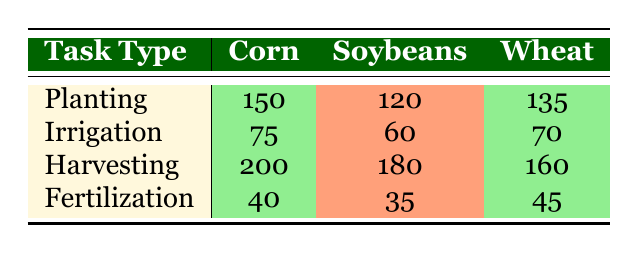What is the total number of labor hours utilized for irrigation across all crops? To find the total hours utilized for irrigation, we add the hours for each crop under irrigation: Corn (75) + Soybeans (60) + Wheat (70) = 205 hours.
Answer: 205 How many hours are spent harvesting corn? The table states that the hours utilized for harvesting corn is 200 hours.
Answer: 200 Is the total amount of hours used for planting soybeans greater than that of fertilization for soybeans? The hours for planting soybeans is 120, while the hours for fertilization is 35. Since 120 is greater than 35, the statement is true.
Answer: Yes What is the average number of labor hours utilized for planting across all crops? To find the average, sum the planting hours: Corn (150) + Soybeans (120) + Wheat (135) = 405. There are 3 crops, so the average is 405 / 3 = 135 hours.
Answer: 135 Which crop requires the most labor hours for harvesting? The harvesting hours for each crop are: Corn (200), Soybeans (180), Wheat (160). The highest value is 200 for corn, indicating it requires the most labor hours for harvesting.
Answer: Corn 